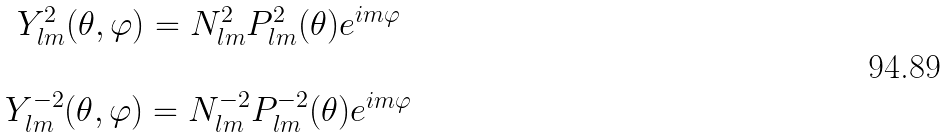<formula> <loc_0><loc_0><loc_500><loc_500>\begin{array} { c } Y ^ { 2 } _ { l m } ( \theta , \varphi ) = N ^ { 2 } _ { l m } P ^ { 2 } _ { l m } ( \theta ) e ^ { i m \varphi } \\ \\ Y ^ { - 2 } _ { l m } ( \theta , \varphi ) = N ^ { - 2 } _ { l m } P ^ { - 2 } _ { l m } ( \theta ) e ^ { i m \varphi } \end{array}</formula> 